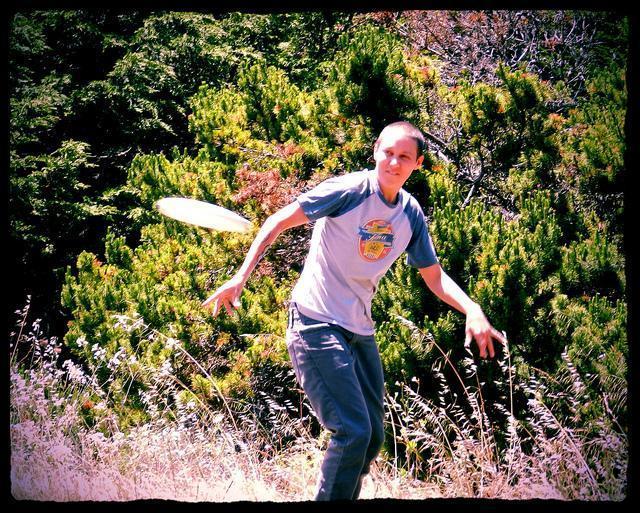How many black umbrella are there?
Give a very brief answer. 0. 